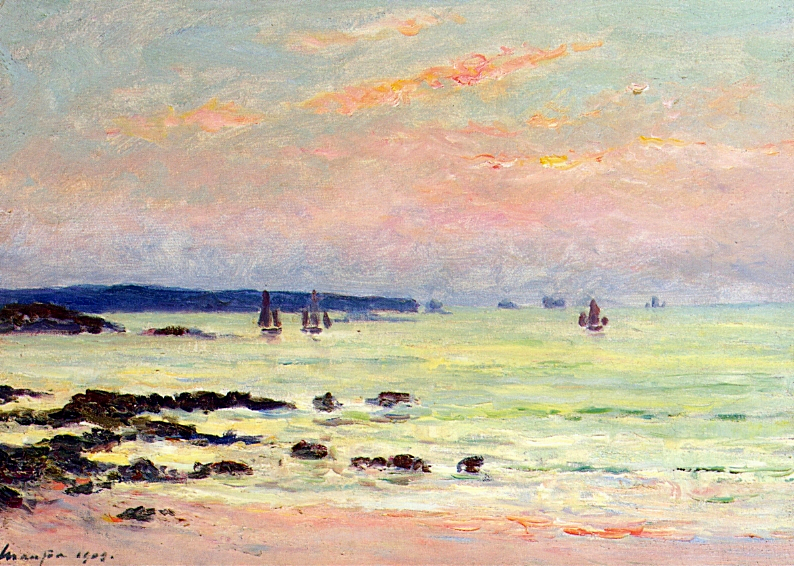What is this photo about? This image is not a photo but an exquisite example of an impressionist painting by Claude Monet from 1874. The artwork is vividly presented with delicate, swift brushstrokes that capture the transient effects of light on the seascape. Monet's unique technique is evident in the sky's gentle pink clouds and the sea's variation from light green to richer shades, suggesting depth and motion. The scene is enlivened by several sailboats that seem to glide effortlessly on the water, against a backdrop of a subtly darkened horizon. This painting is not just a visual treat; it embodies the essence of impressionism, which is to illustrate the beauty of natural landscapes under varying conditions of light and atmosphere. 